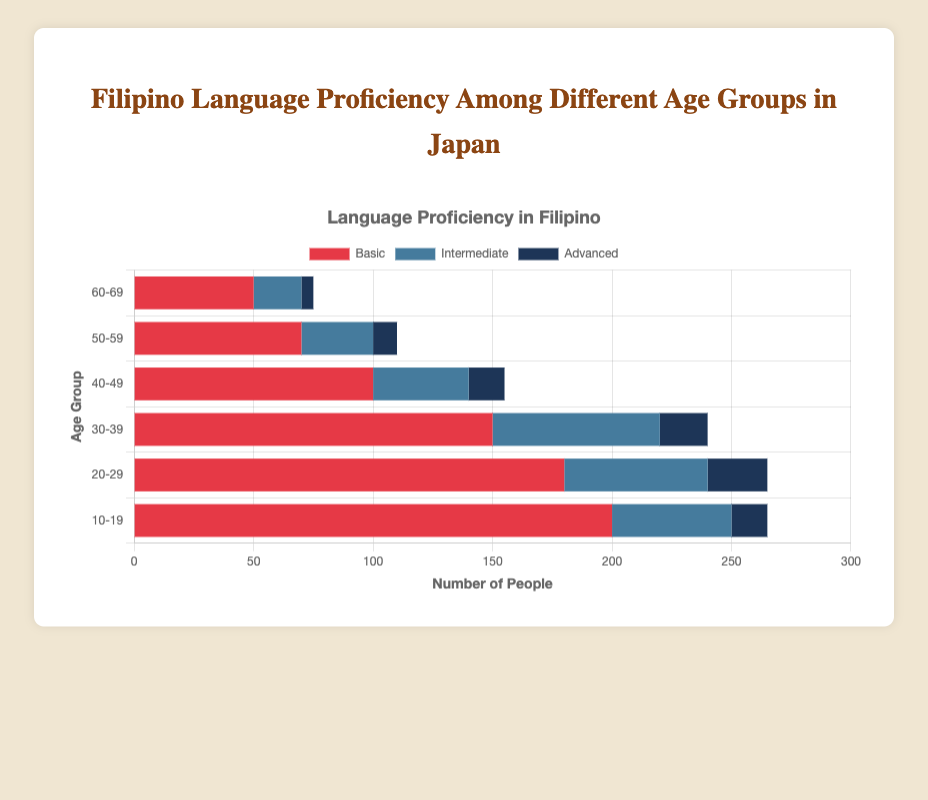What age group has the highest number of people with basic proficiency in Filipino? To identify the age group with the highest number of people with basic proficiency, we look at the bar corresponding to the 'Basic' category across all age groups. The highest bar among the 'Basic' categories is the 10-19 age group with 200 people.
Answer: 10-19 Which age group has the least number of people with advanced proficiency in Filipino? For this question, check the 'Advanced' category bars for each age group and find the smallest one. The smallest bar in the 'Advanced' category corresponds to the 60-69 age group with 5 people.
Answer: 60-69 How many total people in the 40-49 age group have some level of proficiency in Filipino? Sum the number of people with basic, intermediate, and advanced proficiency in the 40-49 age group: 100 (basic) + 40 (intermediate) + 15 (advanced). This gives 100 + 40 + 15 = 155 people.
Answer: 155 Compare the number of people with intermediate proficiency between the age groups 30-39 and 20-29. Which group has more, and by how much? Check the intermediate proficiency for both age groups: 70 people (30-39) versus 60 people (20-29). The 30-39 age group has 10 more people with intermediate proficiency than the 20-29 age group.
Answer: 30-39, 10 What is the combined total number of people with advanced proficiency across all age groups? Add the number of people with advanced proficiency in each age group: 15 (10-19) + 25 (20-29) + 20 (30-39) + 15 (40-49) + 10 (50-59) + 5 (60-69). This gives 15 + 25 + 20 + 15 + 10 + 5 = 90 people.
Answer: 90 Which age group has the least combined total of people with any level of proficiency in Filipino? Calculate the total number of people for each age group by summing their basic, intermediate, and advanced categories, and identify the smallest sum: 
10-19: 200 + 50 + 15 = 265 
20-29: 180 + 60 + 25 = 265 
30-39: 150 + 70 + 20 = 240 
40-49: 100 + 40 + 15 = 155 
50-59: 70 + 30 + 10 = 110 
60-69: 50 + 20 + 5 = 75 
The 60-69 age group has the least combined total with 75 people.
Answer: 60-69 Which proficiency level across all age groups has the highest number of people? Sum up the people across all age groups for each proficiency level: 
Basic: 200 + 180 + 150 + 100 + 70 + 50 = 750 
Intermediate: 50 + 60 + 70 + 40 + 30 + 20 = 270 
Advanced: 15 + 25 + 20 + 15 + 10 + 5 = 90 
The Basic proficiency level has the highest number of people with 750.
Answer: Basic 